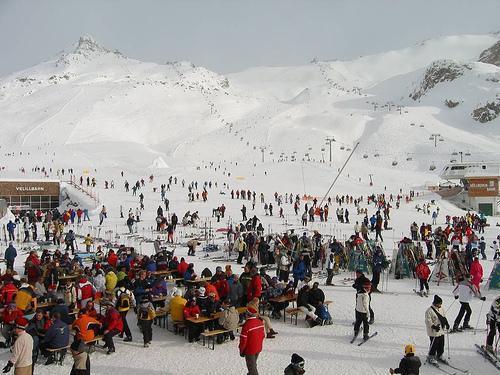How many people are visible?
Give a very brief answer. 1. 